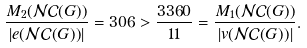<formula> <loc_0><loc_0><loc_500><loc_500>\frac { M _ { 2 } ( \mathcal { N C } ( G ) ) } { | e ( \mathcal { N C } ( G ) ) | } = 3 0 6 > \frac { 3 3 6 0 } { 1 1 } = \frac { M _ { 1 } ( \mathcal { N C } ( G ) ) } { | v ( \mathcal { N C } ( G ) ) | } .</formula> 